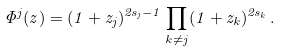Convert formula to latex. <formula><loc_0><loc_0><loc_500><loc_500>\Phi ^ { j } ( z ) = ( 1 + z _ { j } ) ^ { 2 s _ { j } - 1 } \prod _ { k \not = j } ( 1 + z _ { k } ) ^ { 2 s _ { k } } \, .</formula> 